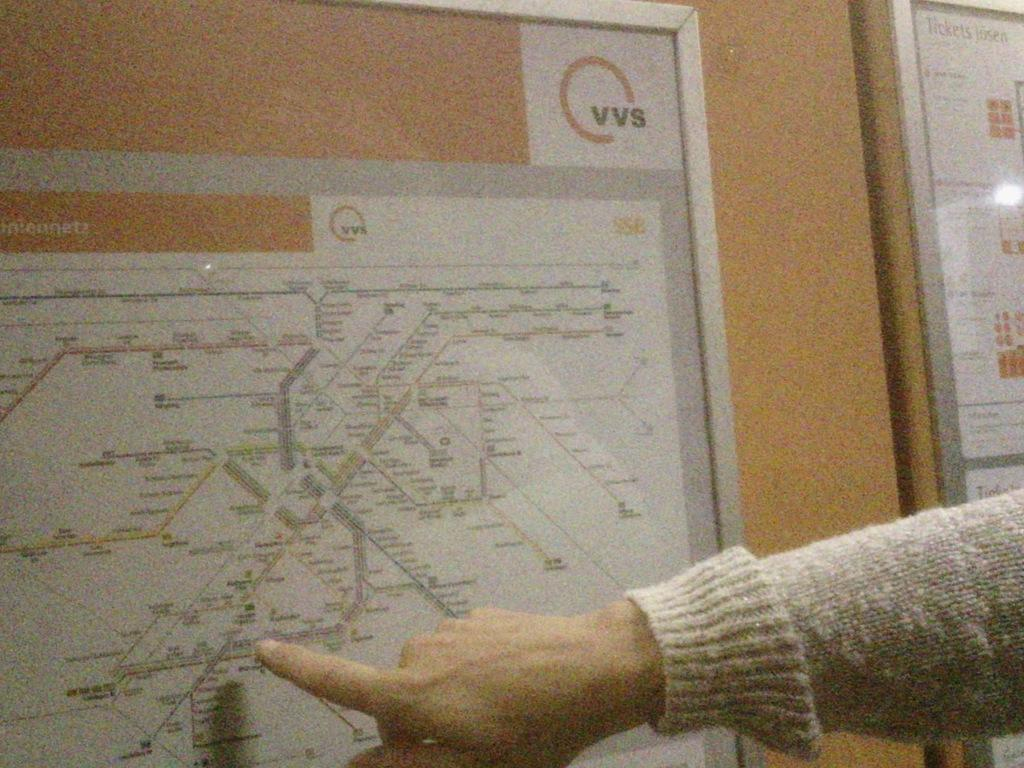What is hanging on the wall in the image? There is a map on the wall in the image. Can you describe any other details visible in the image? Yes, there is a person's hand visible in the image. What type of base can be seen supporting the ocean in the image? There is no base or ocean present in the image; it only features a map on the wall and a person's hand. 